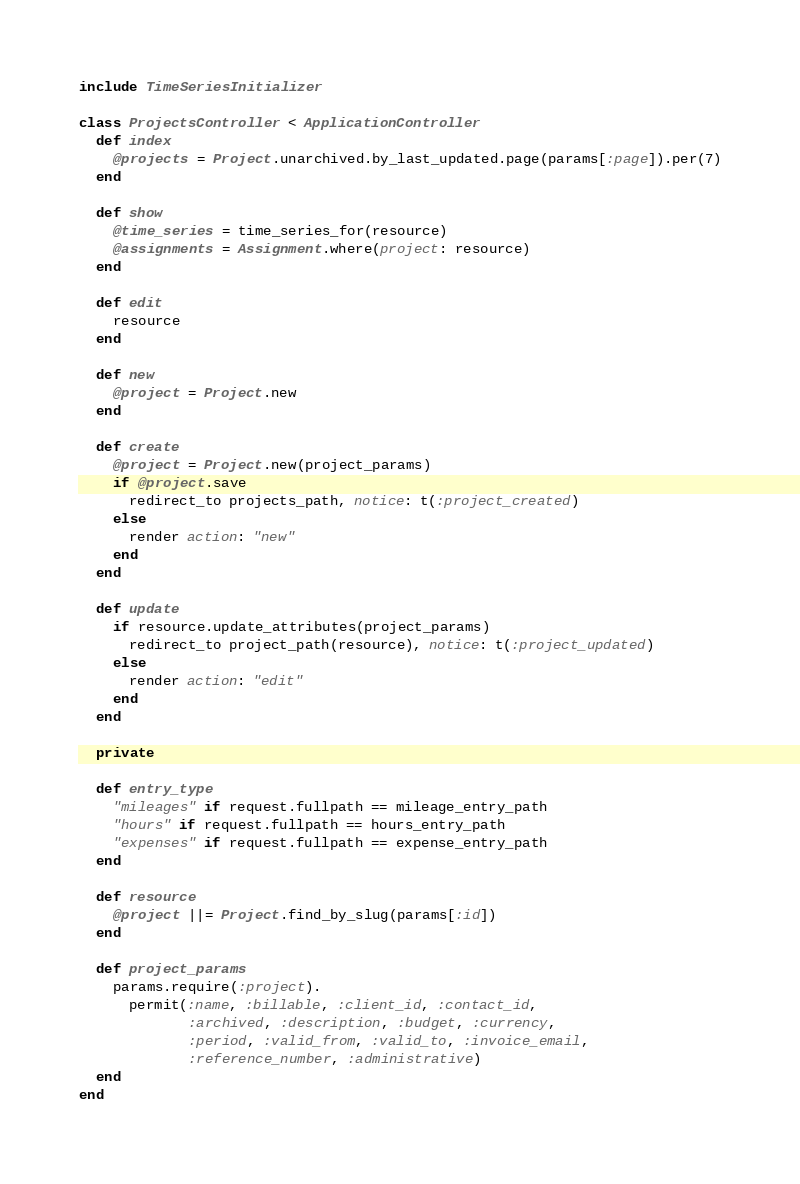Convert code to text. <code><loc_0><loc_0><loc_500><loc_500><_Ruby_>include TimeSeriesInitializer

class ProjectsController < ApplicationController
  def index
    @projects = Project.unarchived.by_last_updated.page(params[:page]).per(7)
  end

  def show
    @time_series = time_series_for(resource)
    @assignments = Assignment.where(project: resource)
  end

  def edit
    resource
  end

  def new
    @project = Project.new
  end

  def create
    @project = Project.new(project_params)
    if @project.save
      redirect_to projects_path, notice: t(:project_created)
    else
      render action: "new"
    end
  end

  def update
    if resource.update_attributes(project_params)
      redirect_to project_path(resource), notice: t(:project_updated)
    else
      render action: "edit"
    end
  end

  private

  def entry_type
    "mileages" if request.fullpath == mileage_entry_path
    "hours" if request.fullpath == hours_entry_path
    "expenses" if request.fullpath == expense_entry_path
  end

  def resource
    @project ||= Project.find_by_slug(params[:id])
  end

  def project_params
    params.require(:project).
      permit(:name, :billable, :client_id, :contact_id,
             :archived, :description, :budget, :currency,
             :period, :valid_from, :valid_to, :invoice_email,
             :reference_number, :administrative)
  end
end
</code> 